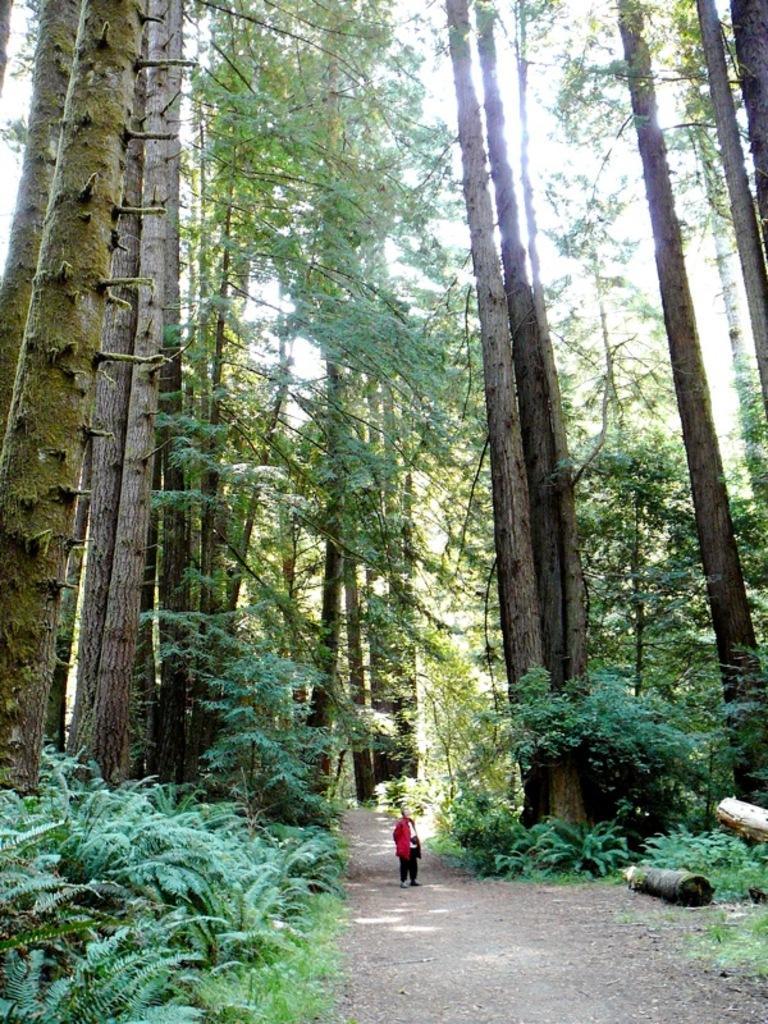Can you describe this image briefly? In this image we can see a person standing. There are groups of trees, plants and the grass in the image. At the top we can see the sky. 